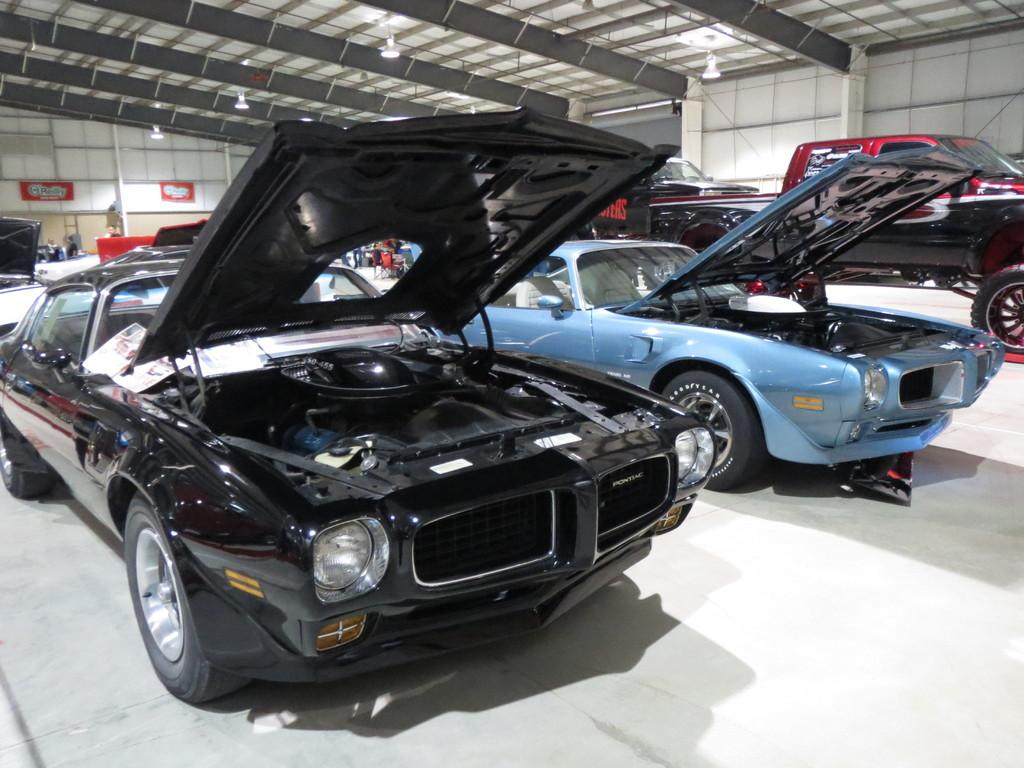What objects are on the floor in the image? There are cars on the floor in the image. What other items can be seen in the image besides the cars? There are boards and lights in the image. What structure is visible in the image? There is a roof in the image. What is visible in the background of the image? There is a wall in the background of the image. How many eggs are visible in the image? There are no eggs present in the image. What type of dog can be seen playing with the cars in the image? There is no dog present in the image; it only features cars, boards, lights, a roof, and a wall in the background. 